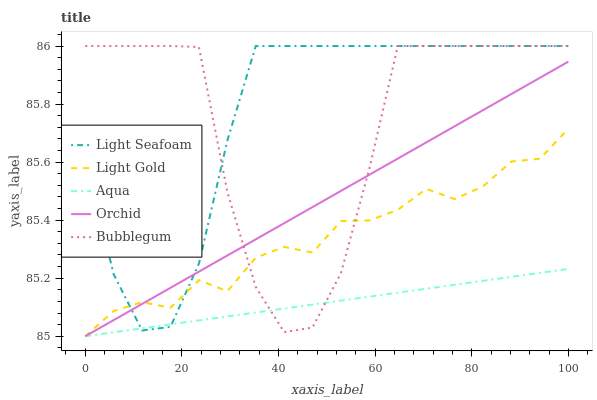Does Aqua have the minimum area under the curve?
Answer yes or no. Yes. Does Light Seafoam have the maximum area under the curve?
Answer yes or no. Yes. Does Light Gold have the minimum area under the curve?
Answer yes or no. No. Does Light Gold have the maximum area under the curve?
Answer yes or no. No. Is Aqua the smoothest?
Answer yes or no. Yes. Is Bubblegum the roughest?
Answer yes or no. Yes. Is Light Seafoam the smoothest?
Answer yes or no. No. Is Light Seafoam the roughest?
Answer yes or no. No. Does Aqua have the lowest value?
Answer yes or no. Yes. Does Light Seafoam have the lowest value?
Answer yes or no. No. Does Bubblegum have the highest value?
Answer yes or no. Yes. Does Light Gold have the highest value?
Answer yes or no. No. Does Light Gold intersect Aqua?
Answer yes or no. Yes. Is Light Gold less than Aqua?
Answer yes or no. No. Is Light Gold greater than Aqua?
Answer yes or no. No. 